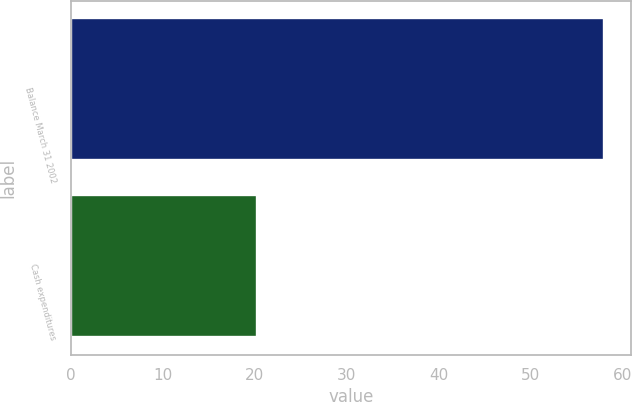Convert chart to OTSL. <chart><loc_0><loc_0><loc_500><loc_500><bar_chart><fcel>Balance March 31 2002<fcel>Cash expenditures<nl><fcel>58<fcel>20.2<nl></chart> 